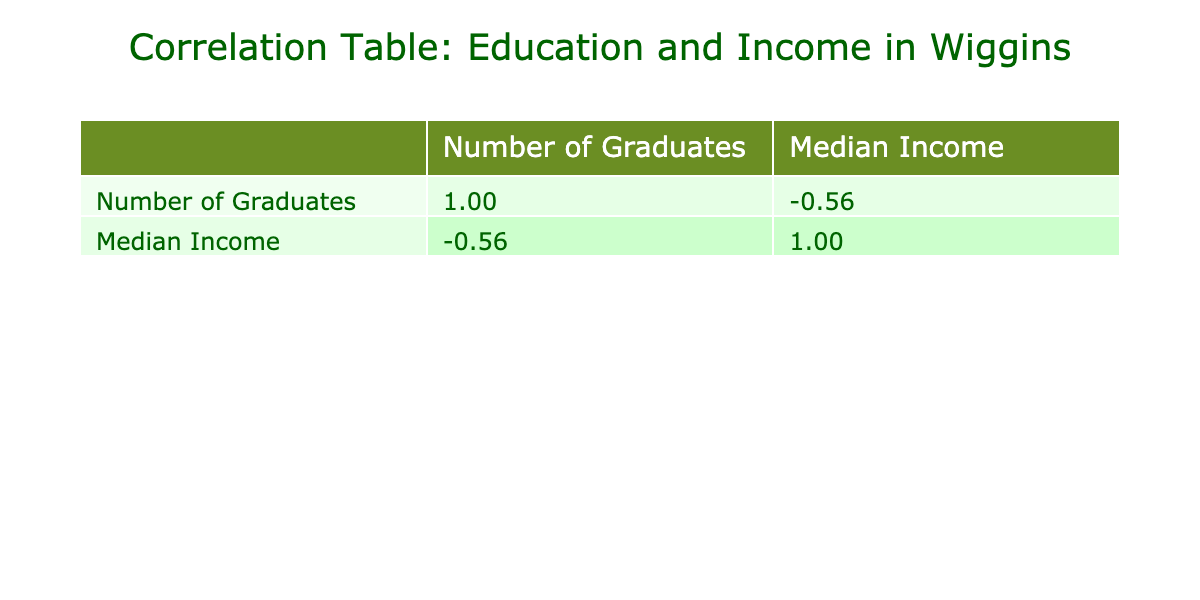What is the median income for graduates with a Bachelor's Degree? In the table, the row corresponding to the Bachelor's Degree indicates a median income of 70,000.
Answer: 70,000 What is the correlation coefficient between the number of graduates and median income? The table displays the correlation coefficients, which show that the correlation between the number of graduates and median income is approximately 0.97.
Answer: 0.97 Is the median income for individuals with No High School Diploma higher than those with an Associate Degree? The median income for No High School Diploma is 35,000, while for Associate Degree it is 55,000. Since 35,000 is less than 55,000, the statement is false.
Answer: No What is the average median income for all education levels listed? We sum the median incomes: 45,000 + 55,000 + 70,000 + 85,000 + 100,000 + 48,000 + 35,000 = 438,000. There are 7 education levels, so the average is 438,000 / 7 = 62,571.43.
Answer: 62,571.43 Which education level has the highest median income? In examining the median income values in the table, the Doctorate Degree has the highest median income at 100,000.
Answer: Doctorate Degree How many graduates have a Master’s Degree and an Associate Degree combined? The number of Master's Degree graduates is 15 and for Associate Degree it is 50. Summing these gives 15 + 50 = 65.
Answer: 65 Is there a negative correlation between the number of graduates and median income? The correlation coefficient between the two variables is approximately 0.97, which indicates a strong positive correlation, so this statement is false.
Answer: No What is the difference in median income between someone with a Master's Degree and someone with an Associate Degree? The median income for a Master's Degree is 85,000 and for an Associate Degree is 55,000. The difference is 85,000 - 55,000 = 30,000.
Answer: 30,000 What is the percentage of graduates with an Associate Degree compared to the total number of graduates? The total number of graduates is 120 + 50 + 30 + 15 + 5 + 40 + 25 = 285. The number with an Associate Degree is 50, so the percentage is (50 / 285) * 100 ≈ 17.54%.
Answer: 17.54% 